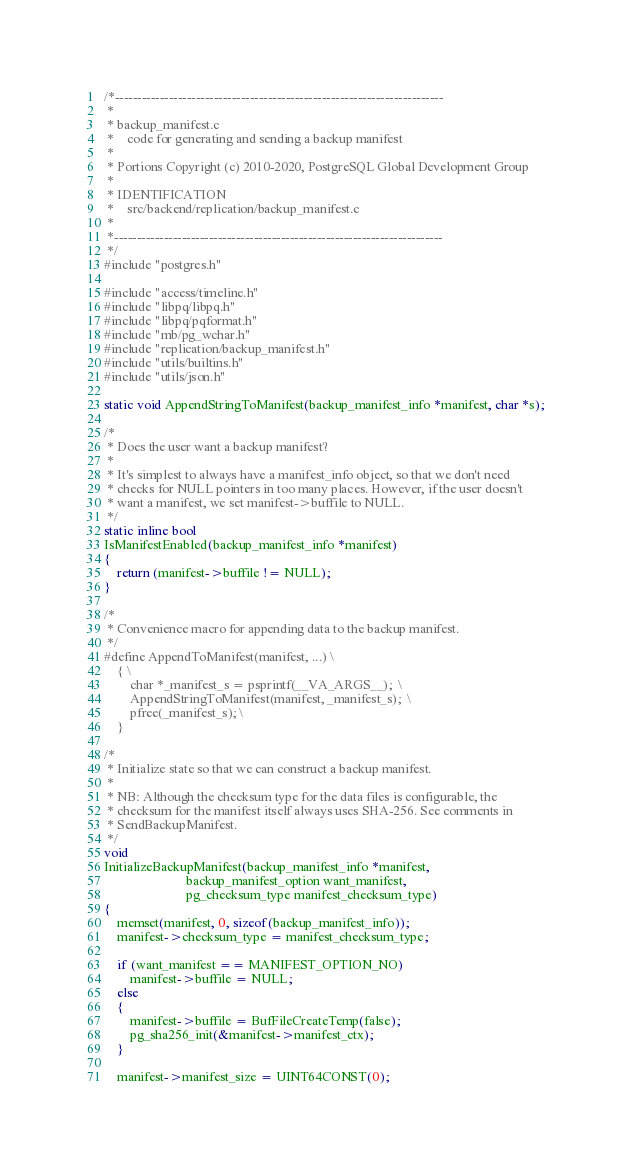Convert code to text. <code><loc_0><loc_0><loc_500><loc_500><_C_>/*-------------------------------------------------------------------------
 *
 * backup_manifest.c
 *	  code for generating and sending a backup manifest
 *
 * Portions Copyright (c) 2010-2020, PostgreSQL Global Development Group
 *
 * IDENTIFICATION
 *	  src/backend/replication/backup_manifest.c
 *
 *-------------------------------------------------------------------------
 */
#include "postgres.h"

#include "access/timeline.h"
#include "libpq/libpq.h"
#include "libpq/pqformat.h"
#include "mb/pg_wchar.h"
#include "replication/backup_manifest.h"
#include "utils/builtins.h"
#include "utils/json.h"

static void AppendStringToManifest(backup_manifest_info *manifest, char *s);

/*
 * Does the user want a backup manifest?
 *
 * It's simplest to always have a manifest_info object, so that we don't need
 * checks for NULL pointers in too many places. However, if the user doesn't
 * want a manifest, we set manifest->buffile to NULL.
 */
static inline bool
IsManifestEnabled(backup_manifest_info *manifest)
{
	return (manifest->buffile != NULL);
}

/*
 * Convenience macro for appending data to the backup manifest.
 */
#define AppendToManifest(manifest, ...) \
	{ \
		char *_manifest_s = psprintf(__VA_ARGS__);	\
		AppendStringToManifest(manifest, _manifest_s);	\
		pfree(_manifest_s);	\
	}

/*
 * Initialize state so that we can construct a backup manifest.
 *
 * NB: Although the checksum type for the data files is configurable, the
 * checksum for the manifest itself always uses SHA-256. See comments in
 * SendBackupManifest.
 */
void
InitializeBackupManifest(backup_manifest_info *manifest,
						 backup_manifest_option want_manifest,
						 pg_checksum_type manifest_checksum_type)
{
	memset(manifest, 0, sizeof(backup_manifest_info));
	manifest->checksum_type = manifest_checksum_type;

	if (want_manifest == MANIFEST_OPTION_NO)
		manifest->buffile = NULL;
	else
	{
		manifest->buffile = BufFileCreateTemp(false);
		pg_sha256_init(&manifest->manifest_ctx);
	}

	manifest->manifest_size = UINT64CONST(0);</code> 